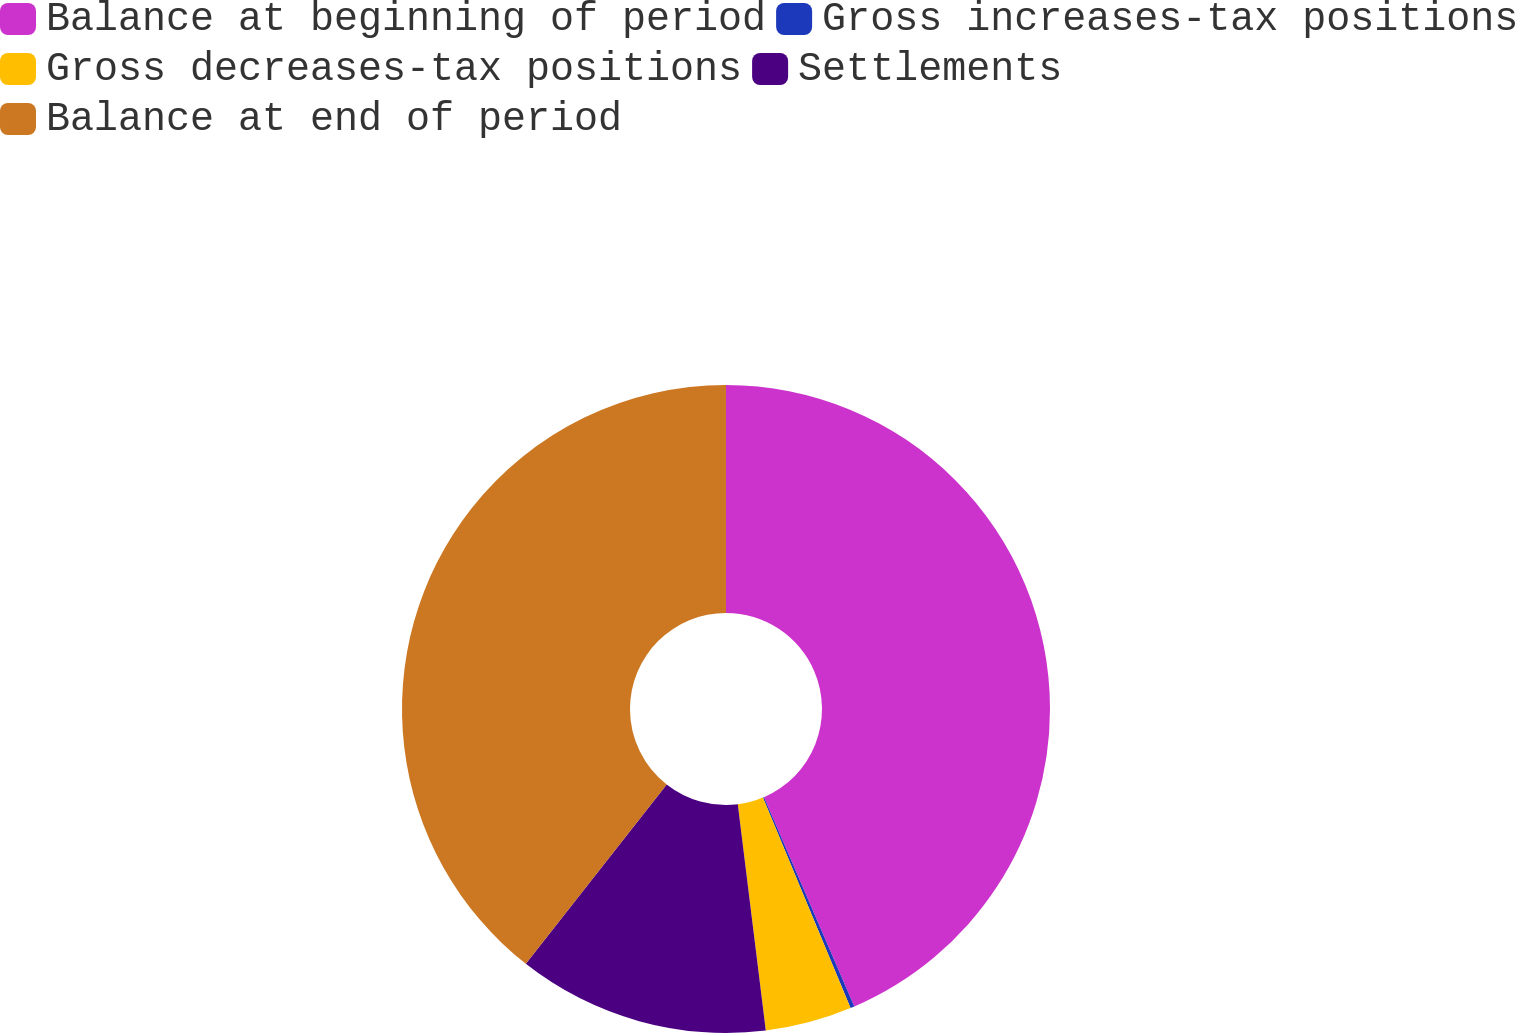Convert chart. <chart><loc_0><loc_0><loc_500><loc_500><pie_chart><fcel>Balance at beginning of period<fcel>Gross increases-tax positions<fcel>Gross decreases-tax positions<fcel>Settlements<fcel>Balance at end of period<nl><fcel>43.52%<fcel>0.2%<fcel>4.32%<fcel>12.56%<fcel>39.4%<nl></chart> 